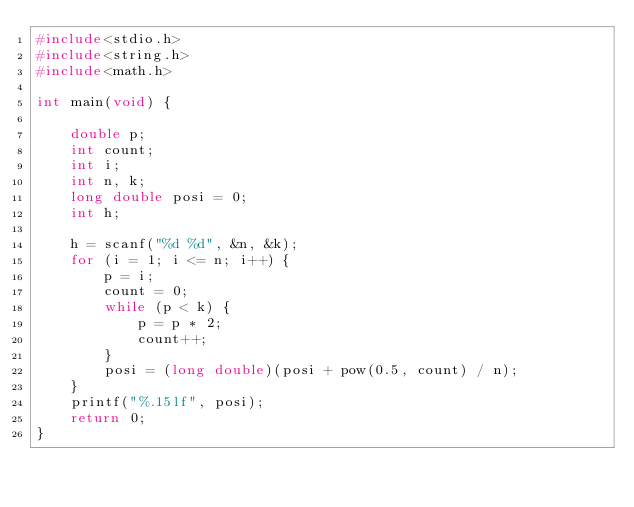Convert code to text. <code><loc_0><loc_0><loc_500><loc_500><_C_>#include<stdio.h>
#include<string.h>
#include<math.h>

int main(void) {

	double p;
	int count;
	int i;
	int n, k;
	long double posi = 0;
	int h;

	h = scanf("%d %d", &n, &k);
	for (i = 1; i <= n; i++) {
		p = i;
		count = 0;
		while (p < k) {
			p = p * 2;
			count++;
		}
		posi = (long double)(posi + pow(0.5, count) / n);
	}
	printf("%.15lf", posi);
	return 0;
}
</code> 